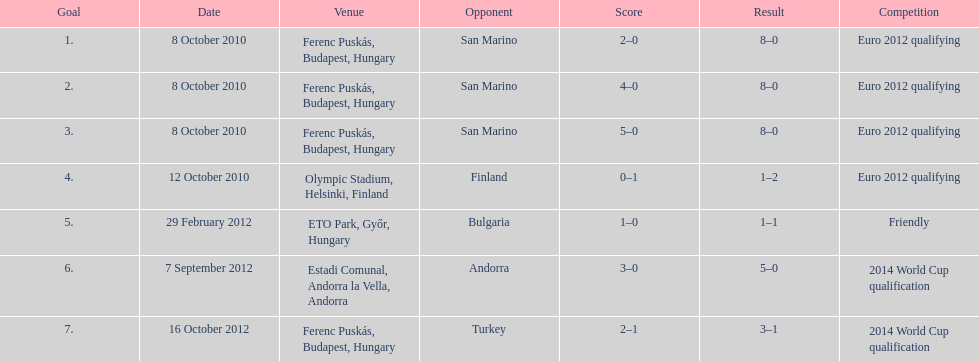How many non-qualifying games did he score in? 1. 